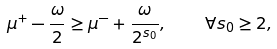Convert formula to latex. <formula><loc_0><loc_0><loc_500><loc_500>\mu ^ { + } - \frac { \omega } { 2 } \geq \mu ^ { - } + \frac { \omega } { 2 ^ { s _ { 0 } } } , \quad \forall s _ { 0 } \geq 2 ,</formula> 